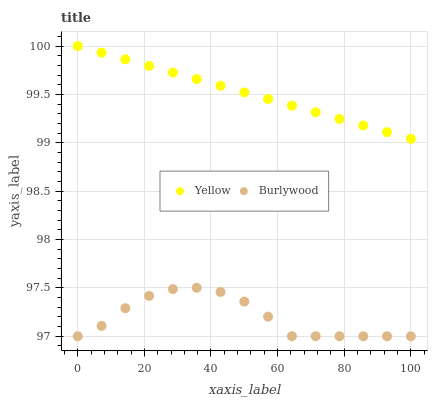Does Burlywood have the minimum area under the curve?
Answer yes or no. Yes. Does Yellow have the maximum area under the curve?
Answer yes or no. Yes. Does Yellow have the minimum area under the curve?
Answer yes or no. No. Is Yellow the smoothest?
Answer yes or no. Yes. Is Burlywood the roughest?
Answer yes or no. Yes. Is Yellow the roughest?
Answer yes or no. No. Does Burlywood have the lowest value?
Answer yes or no. Yes. Does Yellow have the lowest value?
Answer yes or no. No. Does Yellow have the highest value?
Answer yes or no. Yes. Is Burlywood less than Yellow?
Answer yes or no. Yes. Is Yellow greater than Burlywood?
Answer yes or no. Yes. Does Burlywood intersect Yellow?
Answer yes or no. No. 